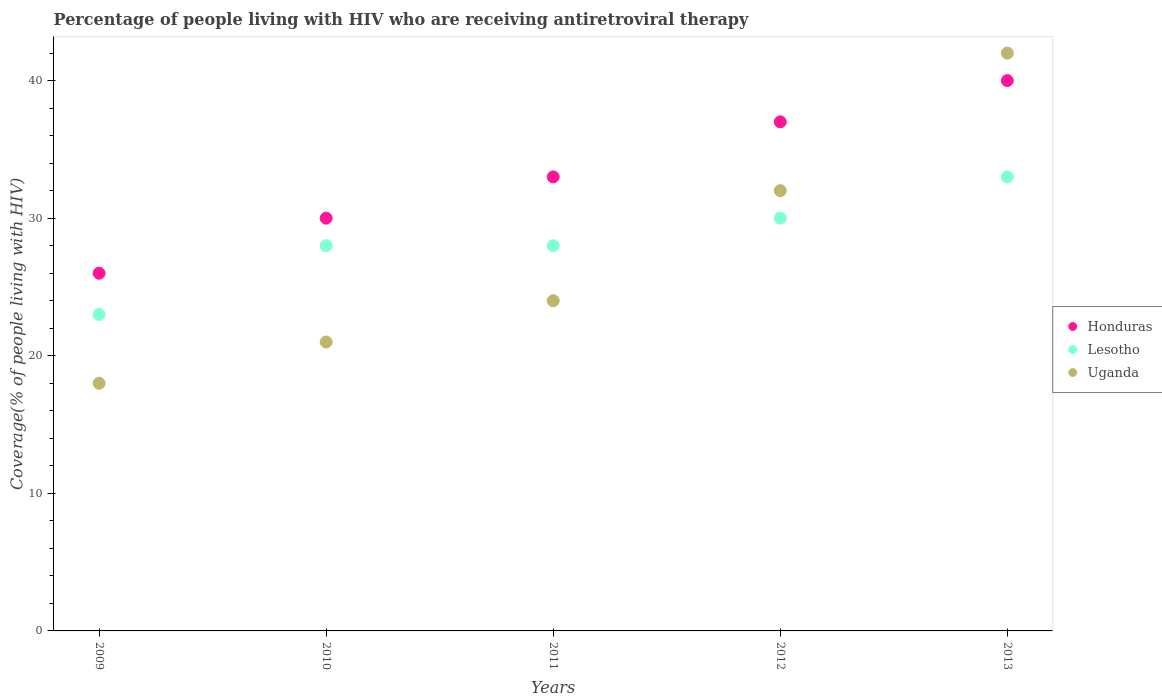How many different coloured dotlines are there?
Keep it short and to the point. 3. What is the percentage of the HIV infected people who are receiving antiretroviral therapy in Uganda in 2013?
Offer a very short reply. 42. Across all years, what is the maximum percentage of the HIV infected people who are receiving antiretroviral therapy in Honduras?
Your response must be concise. 40. Across all years, what is the minimum percentage of the HIV infected people who are receiving antiretroviral therapy in Lesotho?
Your answer should be very brief. 23. What is the total percentage of the HIV infected people who are receiving antiretroviral therapy in Honduras in the graph?
Give a very brief answer. 166. What is the difference between the percentage of the HIV infected people who are receiving antiretroviral therapy in Uganda in 2009 and that in 2011?
Your answer should be very brief. -6. What is the difference between the percentage of the HIV infected people who are receiving antiretroviral therapy in Uganda in 2013 and the percentage of the HIV infected people who are receiving antiretroviral therapy in Lesotho in 2009?
Your response must be concise. 19. What is the average percentage of the HIV infected people who are receiving antiretroviral therapy in Honduras per year?
Your answer should be compact. 33.2. In the year 2010, what is the difference between the percentage of the HIV infected people who are receiving antiretroviral therapy in Uganda and percentage of the HIV infected people who are receiving antiretroviral therapy in Lesotho?
Provide a short and direct response. -7. In how many years, is the percentage of the HIV infected people who are receiving antiretroviral therapy in Uganda greater than 34 %?
Keep it short and to the point. 1. What is the ratio of the percentage of the HIV infected people who are receiving antiretroviral therapy in Uganda in 2010 to that in 2012?
Provide a short and direct response. 0.66. Is the percentage of the HIV infected people who are receiving antiretroviral therapy in Uganda in 2009 less than that in 2010?
Give a very brief answer. Yes. Is the difference between the percentage of the HIV infected people who are receiving antiretroviral therapy in Uganda in 2009 and 2012 greater than the difference between the percentage of the HIV infected people who are receiving antiretroviral therapy in Lesotho in 2009 and 2012?
Your response must be concise. No. What is the difference between the highest and the lowest percentage of the HIV infected people who are receiving antiretroviral therapy in Honduras?
Make the answer very short. 14. Is it the case that in every year, the sum of the percentage of the HIV infected people who are receiving antiretroviral therapy in Lesotho and percentage of the HIV infected people who are receiving antiretroviral therapy in Uganda  is greater than the percentage of the HIV infected people who are receiving antiretroviral therapy in Honduras?
Your answer should be compact. Yes. Does the percentage of the HIV infected people who are receiving antiretroviral therapy in Lesotho monotonically increase over the years?
Make the answer very short. No. Is the percentage of the HIV infected people who are receiving antiretroviral therapy in Uganda strictly less than the percentage of the HIV infected people who are receiving antiretroviral therapy in Honduras over the years?
Offer a terse response. No. How many dotlines are there?
Offer a terse response. 3. How many years are there in the graph?
Your answer should be very brief. 5. Does the graph contain any zero values?
Offer a very short reply. No. Does the graph contain grids?
Keep it short and to the point. No. How many legend labels are there?
Your response must be concise. 3. How are the legend labels stacked?
Offer a terse response. Vertical. What is the title of the graph?
Your response must be concise. Percentage of people living with HIV who are receiving antiretroviral therapy. What is the label or title of the Y-axis?
Your answer should be compact. Coverage(% of people living with HIV). What is the Coverage(% of people living with HIV) in Honduras in 2009?
Keep it short and to the point. 26. What is the Coverage(% of people living with HIV) in Honduras in 2010?
Provide a short and direct response. 30. What is the Coverage(% of people living with HIV) of Lesotho in 2010?
Offer a terse response. 28. What is the Coverage(% of people living with HIV) in Uganda in 2010?
Offer a very short reply. 21. What is the Coverage(% of people living with HIV) of Uganda in 2011?
Offer a very short reply. 24. What is the Coverage(% of people living with HIV) of Lesotho in 2012?
Ensure brevity in your answer.  30. What is the Coverage(% of people living with HIV) of Honduras in 2013?
Give a very brief answer. 40. What is the Coverage(% of people living with HIV) of Lesotho in 2013?
Your answer should be very brief. 33. What is the Coverage(% of people living with HIV) in Uganda in 2013?
Give a very brief answer. 42. Across all years, what is the maximum Coverage(% of people living with HIV) in Lesotho?
Your response must be concise. 33. Across all years, what is the minimum Coverage(% of people living with HIV) of Honduras?
Ensure brevity in your answer.  26. What is the total Coverage(% of people living with HIV) of Honduras in the graph?
Your answer should be very brief. 166. What is the total Coverage(% of people living with HIV) in Lesotho in the graph?
Your answer should be very brief. 142. What is the total Coverage(% of people living with HIV) of Uganda in the graph?
Your response must be concise. 137. What is the difference between the Coverage(% of people living with HIV) in Honduras in 2009 and that in 2010?
Offer a very short reply. -4. What is the difference between the Coverage(% of people living with HIV) in Lesotho in 2009 and that in 2010?
Keep it short and to the point. -5. What is the difference between the Coverage(% of people living with HIV) in Uganda in 2009 and that in 2010?
Your answer should be compact. -3. What is the difference between the Coverage(% of people living with HIV) in Lesotho in 2009 and that in 2011?
Your answer should be very brief. -5. What is the difference between the Coverage(% of people living with HIV) of Uganda in 2009 and that in 2011?
Ensure brevity in your answer.  -6. What is the difference between the Coverage(% of people living with HIV) in Lesotho in 2009 and that in 2012?
Offer a very short reply. -7. What is the difference between the Coverage(% of people living with HIV) of Uganda in 2009 and that in 2012?
Your response must be concise. -14. What is the difference between the Coverage(% of people living with HIV) of Honduras in 2010 and that in 2012?
Provide a short and direct response. -7. What is the difference between the Coverage(% of people living with HIV) of Uganda in 2010 and that in 2012?
Make the answer very short. -11. What is the difference between the Coverage(% of people living with HIV) in Honduras in 2010 and that in 2013?
Provide a succinct answer. -10. What is the difference between the Coverage(% of people living with HIV) of Lesotho in 2010 and that in 2013?
Offer a very short reply. -5. What is the difference between the Coverage(% of people living with HIV) of Honduras in 2011 and that in 2012?
Make the answer very short. -4. What is the difference between the Coverage(% of people living with HIV) of Uganda in 2011 and that in 2012?
Your answer should be compact. -8. What is the difference between the Coverage(% of people living with HIV) of Uganda in 2011 and that in 2013?
Your answer should be very brief. -18. What is the difference between the Coverage(% of people living with HIV) of Lesotho in 2012 and that in 2013?
Offer a terse response. -3. What is the difference between the Coverage(% of people living with HIV) of Uganda in 2012 and that in 2013?
Your answer should be very brief. -10. What is the difference between the Coverage(% of people living with HIV) of Honduras in 2009 and the Coverage(% of people living with HIV) of Uganda in 2010?
Offer a terse response. 5. What is the difference between the Coverage(% of people living with HIV) of Honduras in 2009 and the Coverage(% of people living with HIV) of Uganda in 2011?
Your answer should be very brief. 2. What is the difference between the Coverage(% of people living with HIV) in Lesotho in 2009 and the Coverage(% of people living with HIV) in Uganda in 2011?
Offer a very short reply. -1. What is the difference between the Coverage(% of people living with HIV) in Honduras in 2009 and the Coverage(% of people living with HIV) in Lesotho in 2012?
Keep it short and to the point. -4. What is the difference between the Coverage(% of people living with HIV) of Lesotho in 2009 and the Coverage(% of people living with HIV) of Uganda in 2012?
Ensure brevity in your answer.  -9. What is the difference between the Coverage(% of people living with HIV) in Honduras in 2010 and the Coverage(% of people living with HIV) in Lesotho in 2011?
Offer a terse response. 2. What is the difference between the Coverage(% of people living with HIV) in Honduras in 2010 and the Coverage(% of people living with HIV) in Uganda in 2011?
Provide a short and direct response. 6. What is the difference between the Coverage(% of people living with HIV) of Lesotho in 2010 and the Coverage(% of people living with HIV) of Uganda in 2011?
Give a very brief answer. 4. What is the difference between the Coverage(% of people living with HIV) in Honduras in 2010 and the Coverage(% of people living with HIV) in Uganda in 2012?
Make the answer very short. -2. What is the difference between the Coverage(% of people living with HIV) of Lesotho in 2010 and the Coverage(% of people living with HIV) of Uganda in 2012?
Offer a very short reply. -4. What is the difference between the Coverage(% of people living with HIV) in Honduras in 2010 and the Coverage(% of people living with HIV) in Uganda in 2013?
Make the answer very short. -12. What is the difference between the Coverage(% of people living with HIV) in Honduras in 2011 and the Coverage(% of people living with HIV) in Lesotho in 2012?
Give a very brief answer. 3. What is the difference between the Coverage(% of people living with HIV) of Honduras in 2012 and the Coverage(% of people living with HIV) of Uganda in 2013?
Keep it short and to the point. -5. What is the difference between the Coverage(% of people living with HIV) in Lesotho in 2012 and the Coverage(% of people living with HIV) in Uganda in 2013?
Ensure brevity in your answer.  -12. What is the average Coverage(% of people living with HIV) in Honduras per year?
Your answer should be compact. 33.2. What is the average Coverage(% of people living with HIV) in Lesotho per year?
Your answer should be very brief. 28.4. What is the average Coverage(% of people living with HIV) in Uganda per year?
Offer a terse response. 27.4. In the year 2010, what is the difference between the Coverage(% of people living with HIV) of Honduras and Coverage(% of people living with HIV) of Lesotho?
Give a very brief answer. 2. In the year 2011, what is the difference between the Coverage(% of people living with HIV) of Honduras and Coverage(% of people living with HIV) of Lesotho?
Offer a terse response. 5. In the year 2011, what is the difference between the Coverage(% of people living with HIV) in Honduras and Coverage(% of people living with HIV) in Uganda?
Your answer should be very brief. 9. In the year 2011, what is the difference between the Coverage(% of people living with HIV) in Lesotho and Coverage(% of people living with HIV) in Uganda?
Your answer should be compact. 4. In the year 2012, what is the difference between the Coverage(% of people living with HIV) in Honduras and Coverage(% of people living with HIV) in Lesotho?
Your answer should be compact. 7. In the year 2012, what is the difference between the Coverage(% of people living with HIV) in Lesotho and Coverage(% of people living with HIV) in Uganda?
Your answer should be compact. -2. In the year 2013, what is the difference between the Coverage(% of people living with HIV) of Honduras and Coverage(% of people living with HIV) of Lesotho?
Your answer should be compact. 7. What is the ratio of the Coverage(% of people living with HIV) in Honduras in 2009 to that in 2010?
Your answer should be compact. 0.87. What is the ratio of the Coverage(% of people living with HIV) in Lesotho in 2009 to that in 2010?
Offer a very short reply. 0.82. What is the ratio of the Coverage(% of people living with HIV) of Uganda in 2009 to that in 2010?
Offer a terse response. 0.86. What is the ratio of the Coverage(% of people living with HIV) in Honduras in 2009 to that in 2011?
Give a very brief answer. 0.79. What is the ratio of the Coverage(% of people living with HIV) of Lesotho in 2009 to that in 2011?
Offer a terse response. 0.82. What is the ratio of the Coverage(% of people living with HIV) of Honduras in 2009 to that in 2012?
Provide a short and direct response. 0.7. What is the ratio of the Coverage(% of people living with HIV) of Lesotho in 2009 to that in 2012?
Provide a succinct answer. 0.77. What is the ratio of the Coverage(% of people living with HIV) in Uganda in 2009 to that in 2012?
Give a very brief answer. 0.56. What is the ratio of the Coverage(% of people living with HIV) of Honduras in 2009 to that in 2013?
Your answer should be very brief. 0.65. What is the ratio of the Coverage(% of people living with HIV) of Lesotho in 2009 to that in 2013?
Keep it short and to the point. 0.7. What is the ratio of the Coverage(% of people living with HIV) in Uganda in 2009 to that in 2013?
Your answer should be compact. 0.43. What is the ratio of the Coverage(% of people living with HIV) in Lesotho in 2010 to that in 2011?
Make the answer very short. 1. What is the ratio of the Coverage(% of people living with HIV) in Honduras in 2010 to that in 2012?
Keep it short and to the point. 0.81. What is the ratio of the Coverage(% of people living with HIV) in Uganda in 2010 to that in 2012?
Your answer should be very brief. 0.66. What is the ratio of the Coverage(% of people living with HIV) in Lesotho in 2010 to that in 2013?
Offer a terse response. 0.85. What is the ratio of the Coverage(% of people living with HIV) in Honduras in 2011 to that in 2012?
Ensure brevity in your answer.  0.89. What is the ratio of the Coverage(% of people living with HIV) in Uganda in 2011 to that in 2012?
Offer a very short reply. 0.75. What is the ratio of the Coverage(% of people living with HIV) in Honduras in 2011 to that in 2013?
Offer a terse response. 0.82. What is the ratio of the Coverage(% of people living with HIV) in Lesotho in 2011 to that in 2013?
Provide a succinct answer. 0.85. What is the ratio of the Coverage(% of people living with HIV) of Uganda in 2011 to that in 2013?
Your answer should be very brief. 0.57. What is the ratio of the Coverage(% of people living with HIV) of Honduras in 2012 to that in 2013?
Provide a short and direct response. 0.93. What is the ratio of the Coverage(% of people living with HIV) in Uganda in 2012 to that in 2013?
Your answer should be compact. 0.76. What is the difference between the highest and the second highest Coverage(% of people living with HIV) of Lesotho?
Your answer should be compact. 3. What is the difference between the highest and the second highest Coverage(% of people living with HIV) in Uganda?
Your answer should be compact. 10. What is the difference between the highest and the lowest Coverage(% of people living with HIV) of Honduras?
Your answer should be compact. 14. What is the difference between the highest and the lowest Coverage(% of people living with HIV) of Lesotho?
Offer a terse response. 10. 